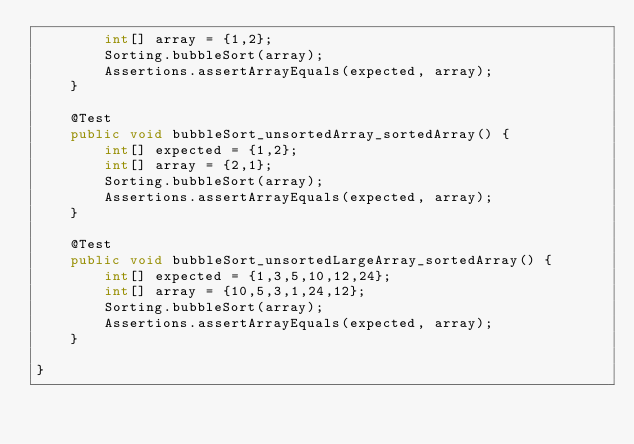<code> <loc_0><loc_0><loc_500><loc_500><_Java_>        int[] array = {1,2};
        Sorting.bubbleSort(array);
        Assertions.assertArrayEquals(expected, array);
    }

    @Test
    public void bubbleSort_unsortedArray_sortedArray() {
        int[] expected = {1,2};
        int[] array = {2,1};
        Sorting.bubbleSort(array);
        Assertions.assertArrayEquals(expected, array);
    }

    @Test
    public void bubbleSort_unsortedLargeArray_sortedArray() {
        int[] expected = {1,3,5,10,12,24};
        int[] array = {10,5,3,1,24,12};
        Sorting.bubbleSort(array);
        Assertions.assertArrayEquals(expected, array);
    }

}
</code> 